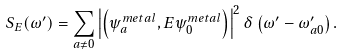<formula> <loc_0><loc_0><loc_500><loc_500>S _ { E } ( \omega ^ { \prime } ) = \sum _ { a \ne 0 } \left | \left ( \psi ^ { m e t a l } _ { a } , { E } \psi ^ { m e t a l } _ { 0 } \right ) \right | ^ { 2 } \delta \left ( \omega ^ { \prime } - \omega ^ { \prime } _ { a 0 } \right ) .</formula> 